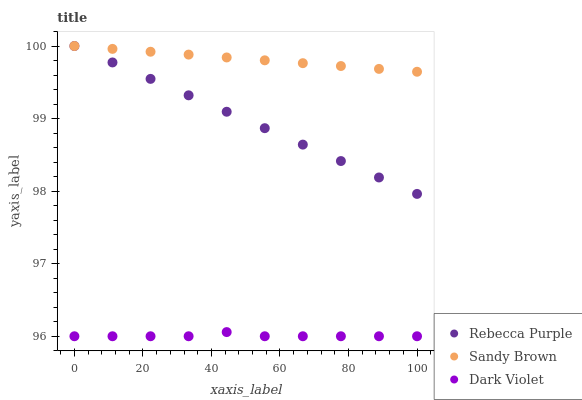Does Dark Violet have the minimum area under the curve?
Answer yes or no. Yes. Does Sandy Brown have the maximum area under the curve?
Answer yes or no. Yes. Does Rebecca Purple have the minimum area under the curve?
Answer yes or no. No. Does Rebecca Purple have the maximum area under the curve?
Answer yes or no. No. Is Sandy Brown the smoothest?
Answer yes or no. Yes. Is Dark Violet the roughest?
Answer yes or no. Yes. Is Rebecca Purple the smoothest?
Answer yes or no. No. Is Rebecca Purple the roughest?
Answer yes or no. No. Does Dark Violet have the lowest value?
Answer yes or no. Yes. Does Rebecca Purple have the lowest value?
Answer yes or no. No. Does Rebecca Purple have the highest value?
Answer yes or no. Yes. Does Dark Violet have the highest value?
Answer yes or no. No. Is Dark Violet less than Rebecca Purple?
Answer yes or no. Yes. Is Rebecca Purple greater than Dark Violet?
Answer yes or no. Yes. Does Sandy Brown intersect Rebecca Purple?
Answer yes or no. Yes. Is Sandy Brown less than Rebecca Purple?
Answer yes or no. No. Is Sandy Brown greater than Rebecca Purple?
Answer yes or no. No. Does Dark Violet intersect Rebecca Purple?
Answer yes or no. No. 